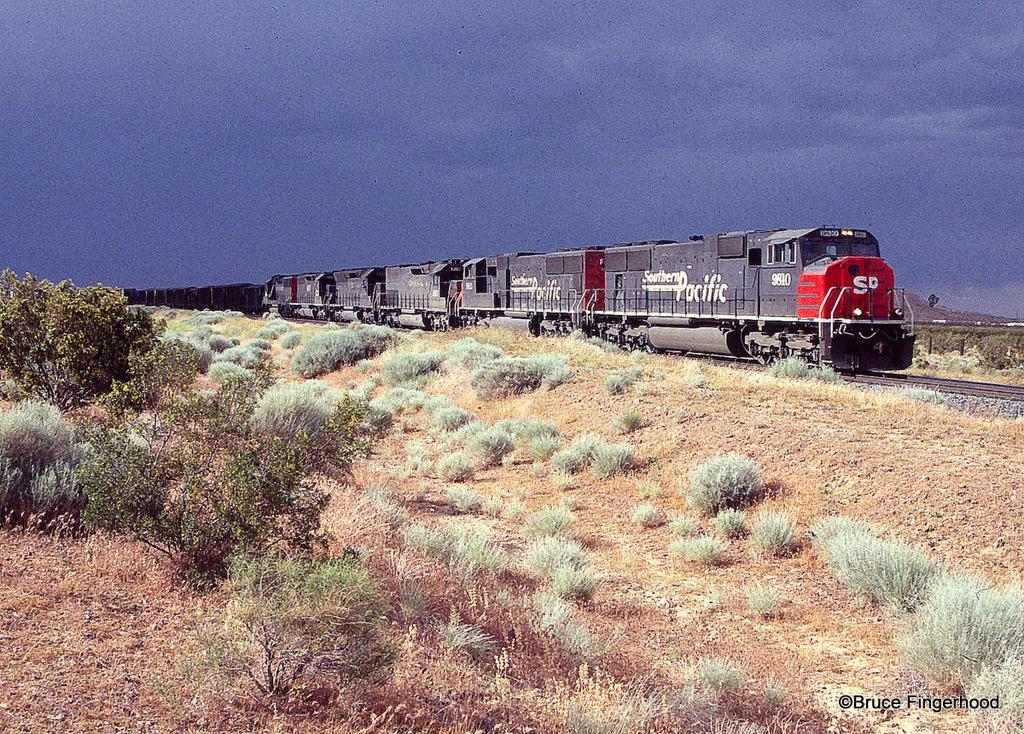Please provide a concise description of this image. In this image I can see on the left side there are trees. In the middle a train is moving on the railway track, it is in black color, at the top it is the cloudy sky. 